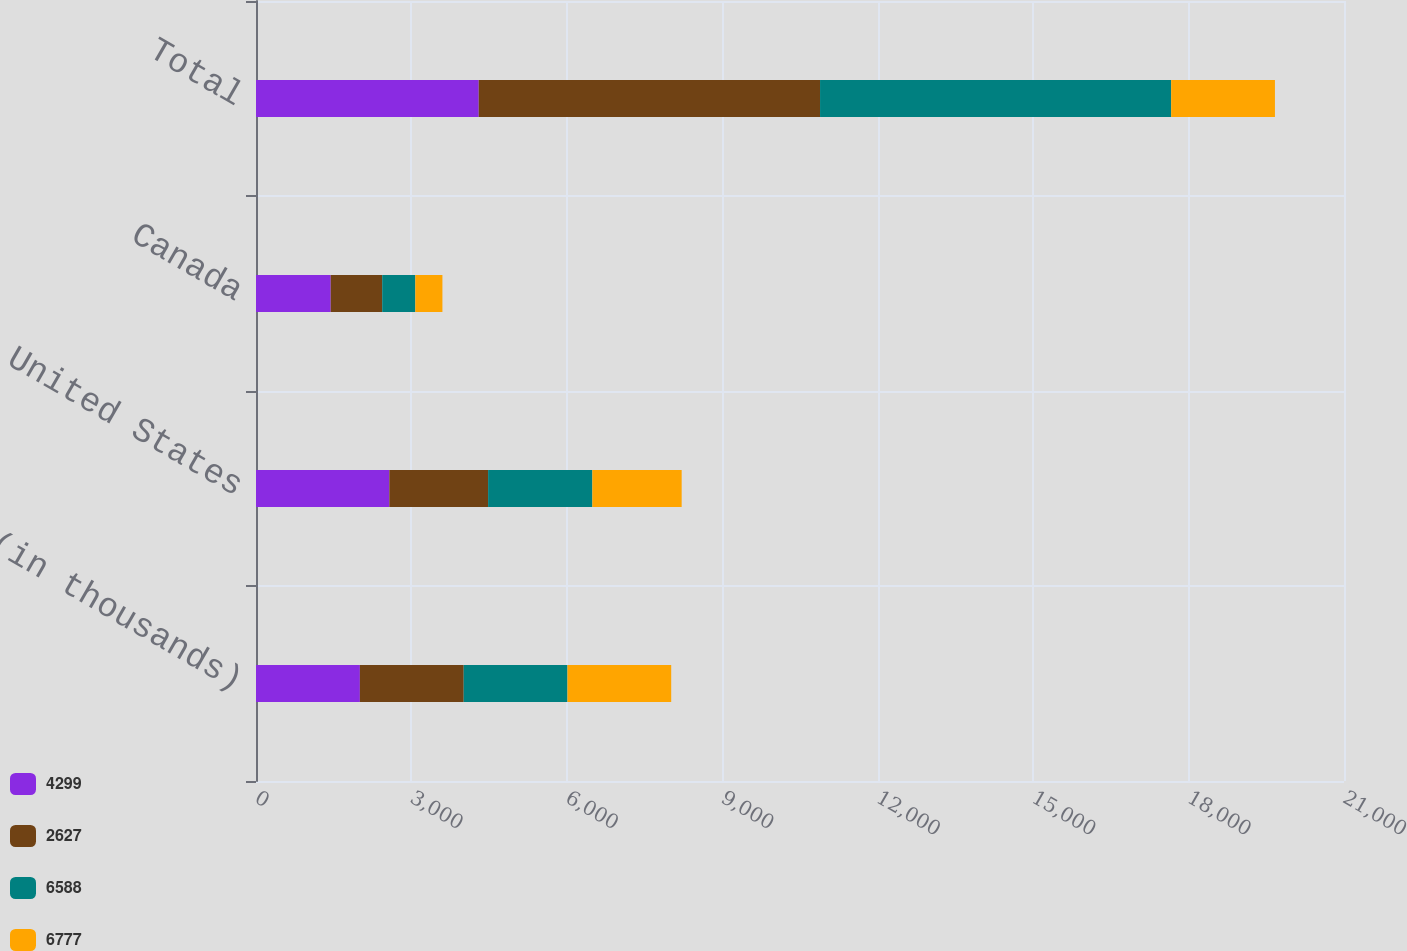Convert chart. <chart><loc_0><loc_0><loc_500><loc_500><stacked_bar_chart><ecel><fcel>(in thousands)<fcel>United States<fcel>Canada<fcel>Total<nl><fcel>4299<fcel>2005<fcel>2574<fcel>1442<fcel>4299<nl><fcel>2627<fcel>2004<fcel>1906<fcel>994<fcel>6588<nl><fcel>6588<fcel>2003<fcel>2012<fcel>639<fcel>6777<nl><fcel>6777<fcel>2002<fcel>1724<fcel>523<fcel>2003<nl></chart> 